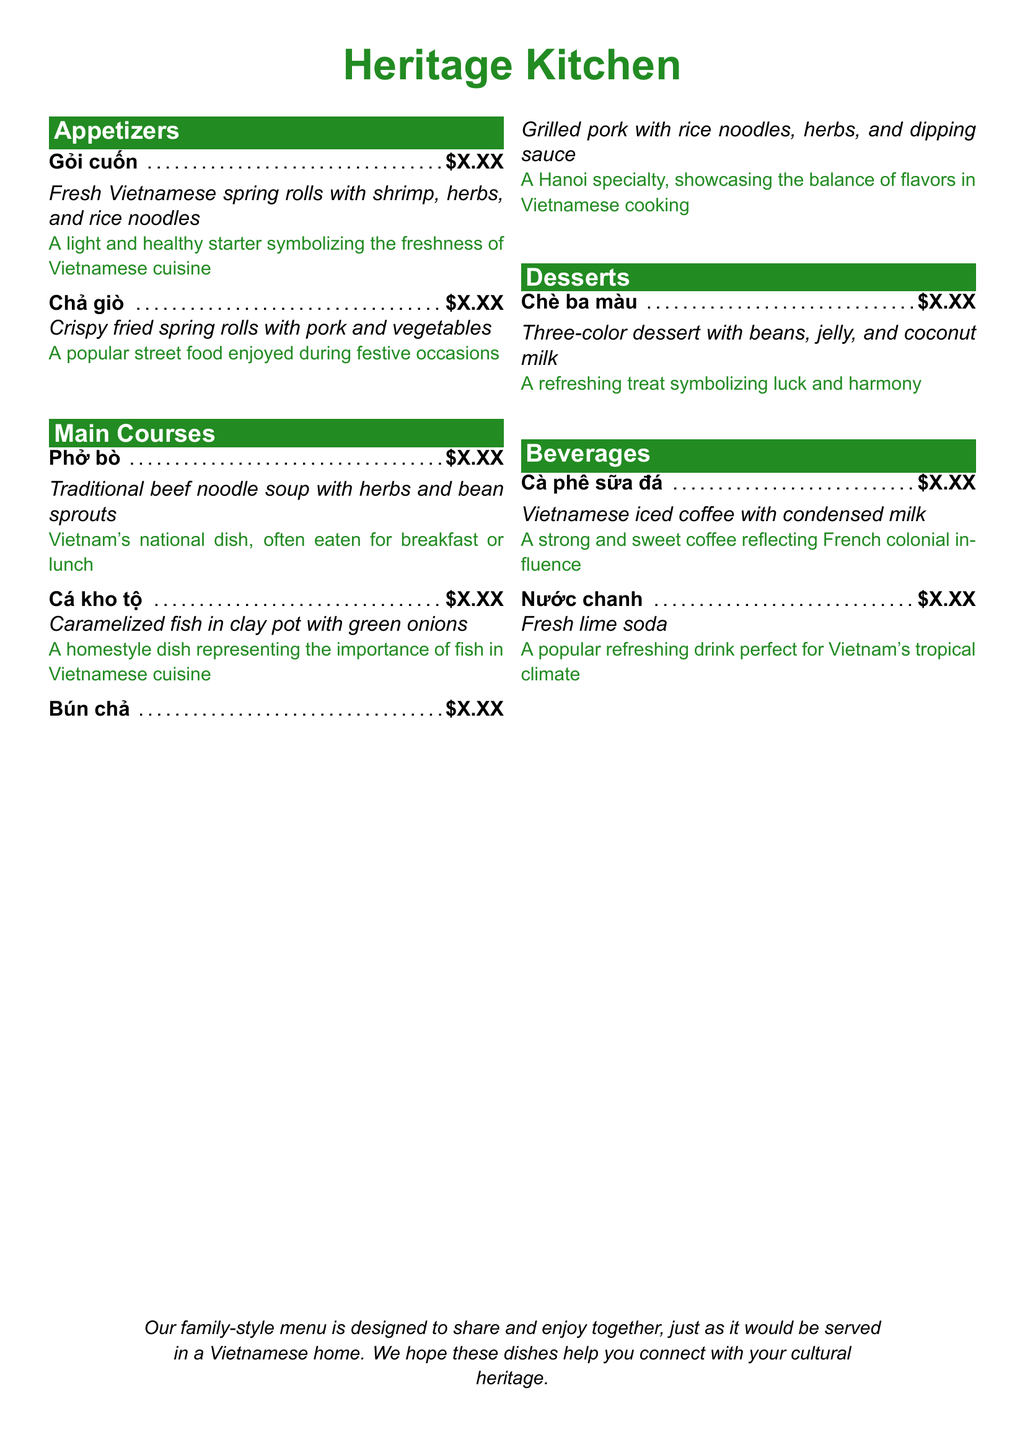What is the name of the restaurant? The name of the restaurant is shown at the top of the menu in a large font.
Answer: Heritage Kitchen What is the price of Gỏi cuốn? The price is indicated next to the menu item in the appetizers section.
Answer: $X.XX Which beverage reflects French colonial influence? This beverage is noted for its historical significance in the menu under beverages.
Answer: Cà phê sữa đá What is the national dish of Vietnam? The menu clearly states this dish as Vietnam's national dish in the main courses section.
Answer: Phở bò What type of dessert symbolizes luck and harmony? The menu lists a specific dessert with this cultural significance.
Answer: Chè ba màu How many appetizers are listed? The number of items in the appetizers section can be counted from the menu.
Answer: 2 What is the predominant theme of the menu? The document explains the overall serving style and purpose of the menu.
Answer: Family-style Which main course is a Hanoi specialty? This main course is explicitly identified in the main courses section.
Answer: Bún chả What do Chả giò represent in Vietnamese culture? The menu provides a brief cultural explanation for this appetizer.
Answer: Popular street food enjoyed during festive occasions 